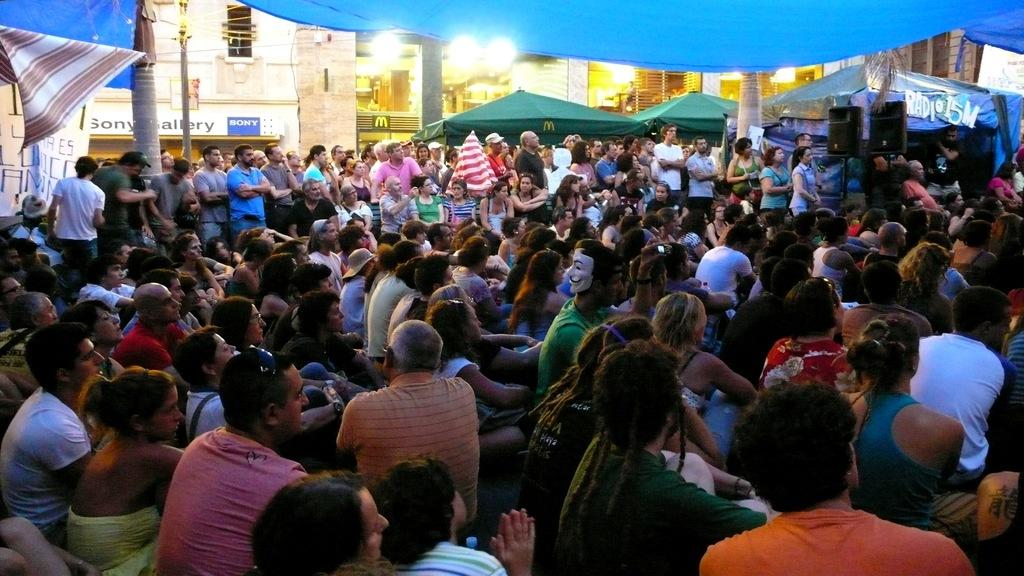How many people are in the image? There is a group of people in the image. What are the people in the image doing? The people are sitting. What can be observed about the clothing of the people in the image? The people are wearing different color dresses. What can be seen in the background of the image? There are tents, buildings, windows, and boards visible in the background. What type of industry is depicted in the image? There is no industry depicted in the image; it features a group of people sitting and wearing different color dresses, along with various background elements. Can you describe the action of the ants in the image? There are no ants present in the image. 